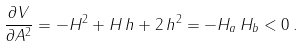<formula> <loc_0><loc_0><loc_500><loc_500>\frac { \partial V } { \partial A ^ { 2 } } = - H ^ { 2 } + H \, h + 2 \, h ^ { 2 } = - H _ { a } \, H _ { b } < 0 \, .</formula> 